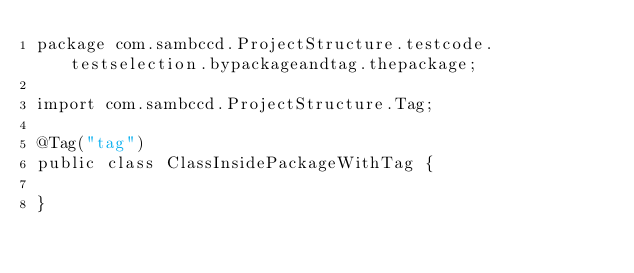<code> <loc_0><loc_0><loc_500><loc_500><_Java_>package com.sambccd.ProjectStructure.testcode.testselection.bypackageandtag.thepackage;

import com.sambccd.ProjectStructure.Tag;

@Tag("tag")
public class ClassInsidePackageWithTag {

}
</code> 